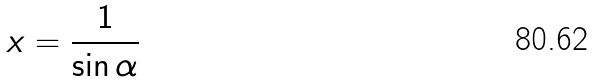Convert formula to latex. <formula><loc_0><loc_0><loc_500><loc_500>x = \frac { 1 } { \sin \alpha }</formula> 